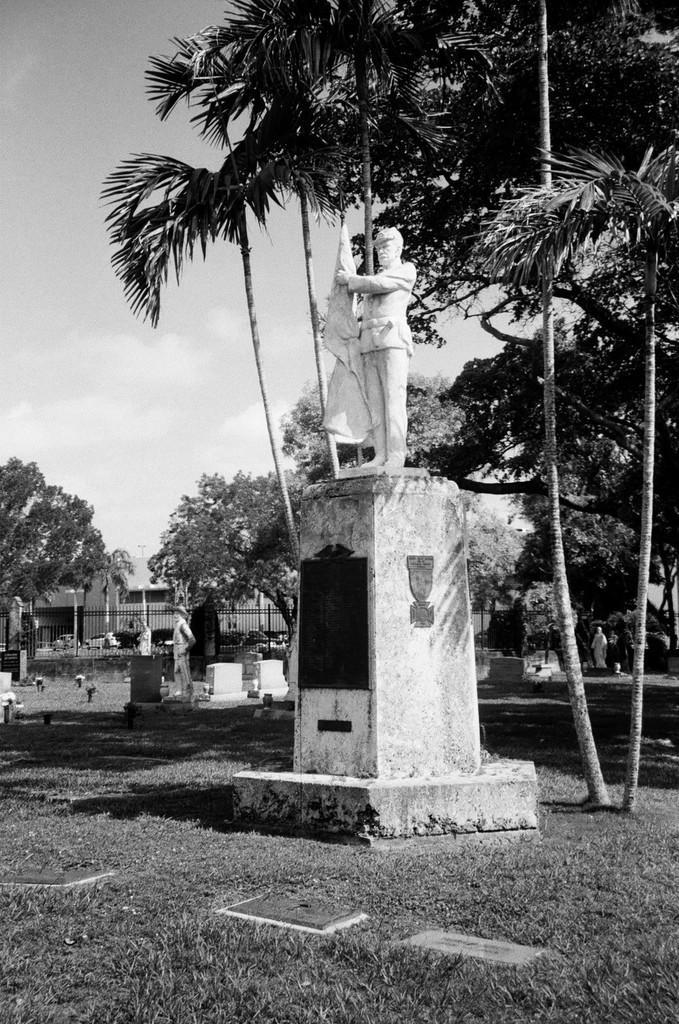Describe this image in one or two sentences. In this image I can see the statue of the person. In the background I can see few more statues, many trees, railing and the building. I can also see the sky in the back. I can see this is a black and white image. 